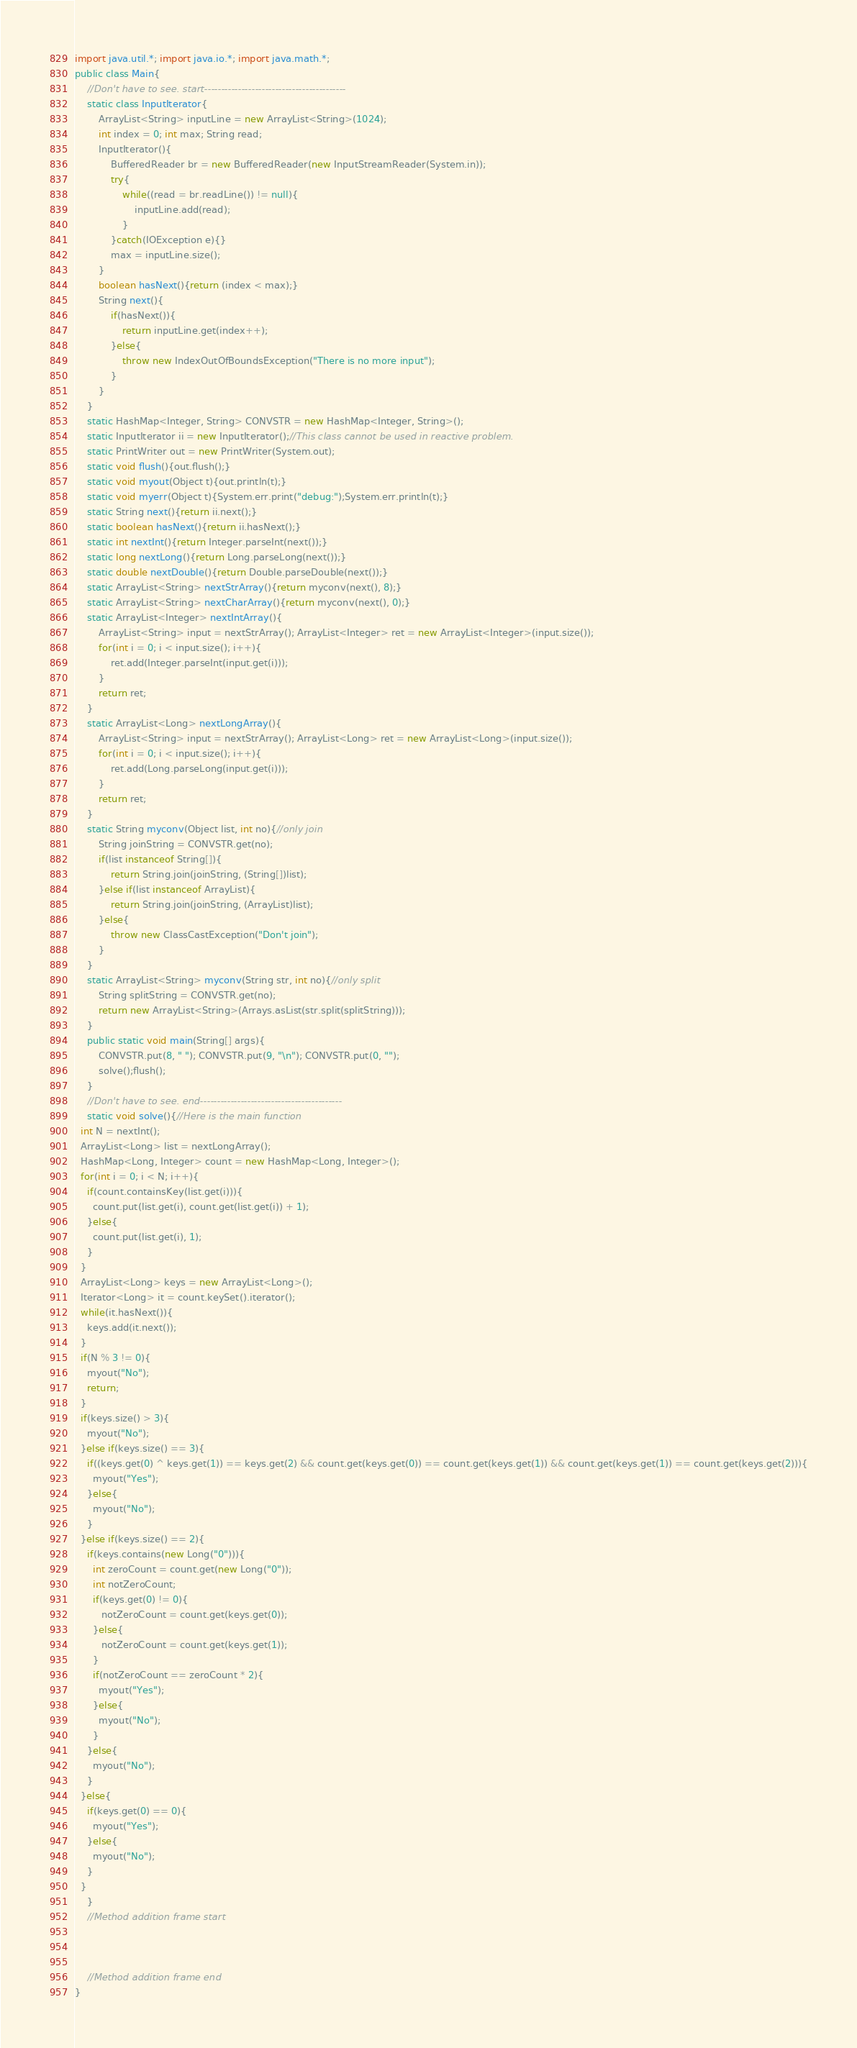Convert code to text. <code><loc_0><loc_0><loc_500><loc_500><_Java_>import java.util.*; import java.io.*; import java.math.*;
public class Main{
	//Don't have to see. start------------------------------------------
	static class InputIterator{
		ArrayList<String> inputLine = new ArrayList<String>(1024);
		int index = 0; int max; String read;
		InputIterator(){
			BufferedReader br = new BufferedReader(new InputStreamReader(System.in));
			try{
				while((read = br.readLine()) != null){
					inputLine.add(read);
				}
			}catch(IOException e){}
			max = inputLine.size();
		}
		boolean hasNext(){return (index < max);}
		String next(){
			if(hasNext()){
				return inputLine.get(index++);
			}else{
				throw new IndexOutOfBoundsException("There is no more input");
			}
		}
	}
	static HashMap<Integer, String> CONVSTR = new HashMap<Integer, String>();
	static InputIterator ii = new InputIterator();//This class cannot be used in reactive problem.
	static PrintWriter out = new PrintWriter(System.out);
	static void flush(){out.flush();}
	static void myout(Object t){out.println(t);}
	static void myerr(Object t){System.err.print("debug:");System.err.println(t);}
	static String next(){return ii.next();}
	static boolean hasNext(){return ii.hasNext();}
	static int nextInt(){return Integer.parseInt(next());}
	static long nextLong(){return Long.parseLong(next());}
	static double nextDouble(){return Double.parseDouble(next());}
	static ArrayList<String> nextStrArray(){return myconv(next(), 8);}
	static ArrayList<String> nextCharArray(){return myconv(next(), 0);}
	static ArrayList<Integer> nextIntArray(){
		ArrayList<String> input = nextStrArray(); ArrayList<Integer> ret = new ArrayList<Integer>(input.size());
		for(int i = 0; i < input.size(); i++){
			ret.add(Integer.parseInt(input.get(i)));
		}
		return ret;
	}
	static ArrayList<Long> nextLongArray(){
		ArrayList<String> input = nextStrArray(); ArrayList<Long> ret = new ArrayList<Long>(input.size());
		for(int i = 0; i < input.size(); i++){
			ret.add(Long.parseLong(input.get(i)));
		}
		return ret;
	}
	static String myconv(Object list, int no){//only join
		String joinString = CONVSTR.get(no);
		if(list instanceof String[]){
			return String.join(joinString, (String[])list);
		}else if(list instanceof ArrayList){
			return String.join(joinString, (ArrayList)list);
		}else{
			throw new ClassCastException("Don't join");
		}
	}
	static ArrayList<String> myconv(String str, int no){//only split
		String splitString = CONVSTR.get(no);
		return new ArrayList<String>(Arrays.asList(str.split(splitString)));
	}
	public static void main(String[] args){
		CONVSTR.put(8, " "); CONVSTR.put(9, "\n"); CONVSTR.put(0, "");
		solve();flush();
	}
	//Don't have to see. end------------------------------------------
	static void solve(){//Here is the main function
  int N = nextInt();
  ArrayList<Long> list = nextLongArray();
  HashMap<Long, Integer> count = new HashMap<Long, Integer>();
  for(int i = 0; i < N; i++){
    if(count.containsKey(list.get(i))){
      count.put(list.get(i), count.get(list.get(i)) + 1);
    }else{
      count.put(list.get(i), 1);
    }
  }
  ArrayList<Long> keys = new ArrayList<Long>();
  Iterator<Long> it = count.keySet().iterator();
  while(it.hasNext()){
    keys.add(it.next());
  }
  if(N % 3 != 0){
    myout("No");
    return;
  }
  if(keys.size() > 3){
    myout("No");
  }else if(keys.size() == 3){
    if((keys.get(0) ^ keys.get(1)) == keys.get(2) && count.get(keys.get(0)) == count.get(keys.get(1)) && count.get(keys.get(1)) == count.get(keys.get(2))){
      myout("Yes");
    }else{
      myout("No");
    }
  }else if(keys.size() == 2){
    if(keys.contains(new Long("0"))){
      int zeroCount = count.get(new Long("0"));
      int notZeroCount;
      if(keys.get(0) != 0){
         notZeroCount = count.get(keys.get(0));
      }else{
         notZeroCount = count.get(keys.get(1));
      }
      if(notZeroCount == zeroCount * 2){
        myout("Yes");
      }else{
        myout("No");
      }
    }else{
      myout("No");
    }
  }else{
    if(keys.get(0) == 0){
      myout("Yes");
    }else{
      myout("No");
    }
  }
	}
	//Method addition frame start



	//Method addition frame end
}
</code> 